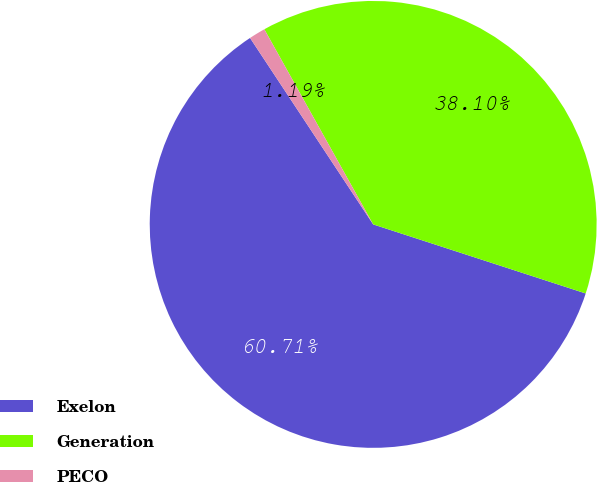Convert chart to OTSL. <chart><loc_0><loc_0><loc_500><loc_500><pie_chart><fcel>Exelon<fcel>Generation<fcel>PECO<nl><fcel>60.71%<fcel>38.1%<fcel>1.19%<nl></chart> 